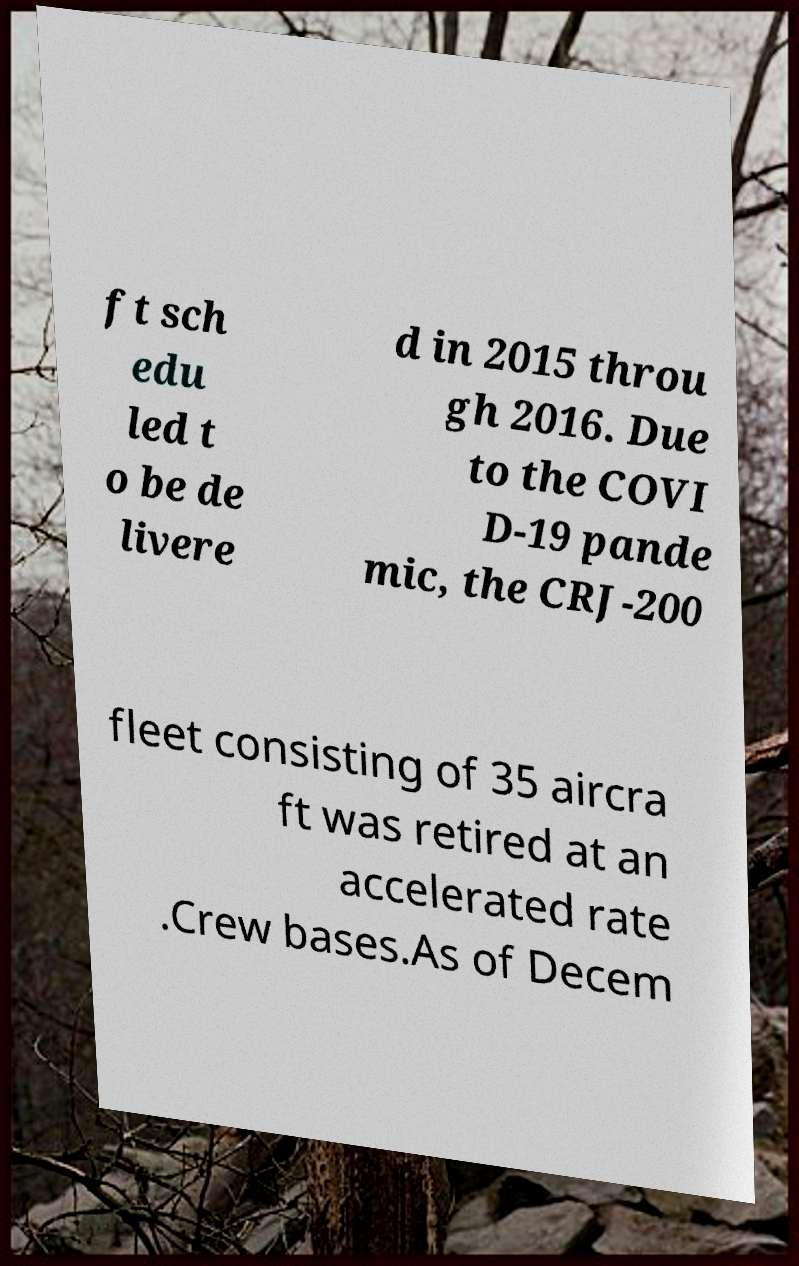Can you read and provide the text displayed in the image?This photo seems to have some interesting text. Can you extract and type it out for me? ft sch edu led t o be de livere d in 2015 throu gh 2016. Due to the COVI D-19 pande mic, the CRJ-200 fleet consisting of 35 aircra ft was retired at an accelerated rate .Crew bases.As of Decem 